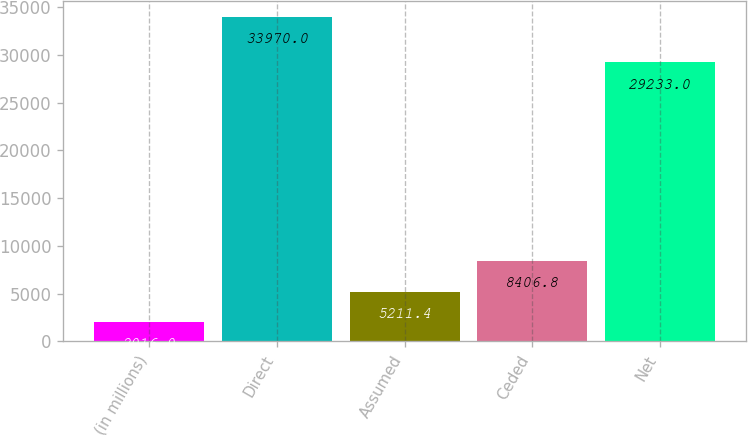<chart> <loc_0><loc_0><loc_500><loc_500><bar_chart><fcel>(in millions)<fcel>Direct<fcel>Assumed<fcel>Ceded<fcel>Net<nl><fcel>2016<fcel>33970<fcel>5211.4<fcel>8406.8<fcel>29233<nl></chart> 